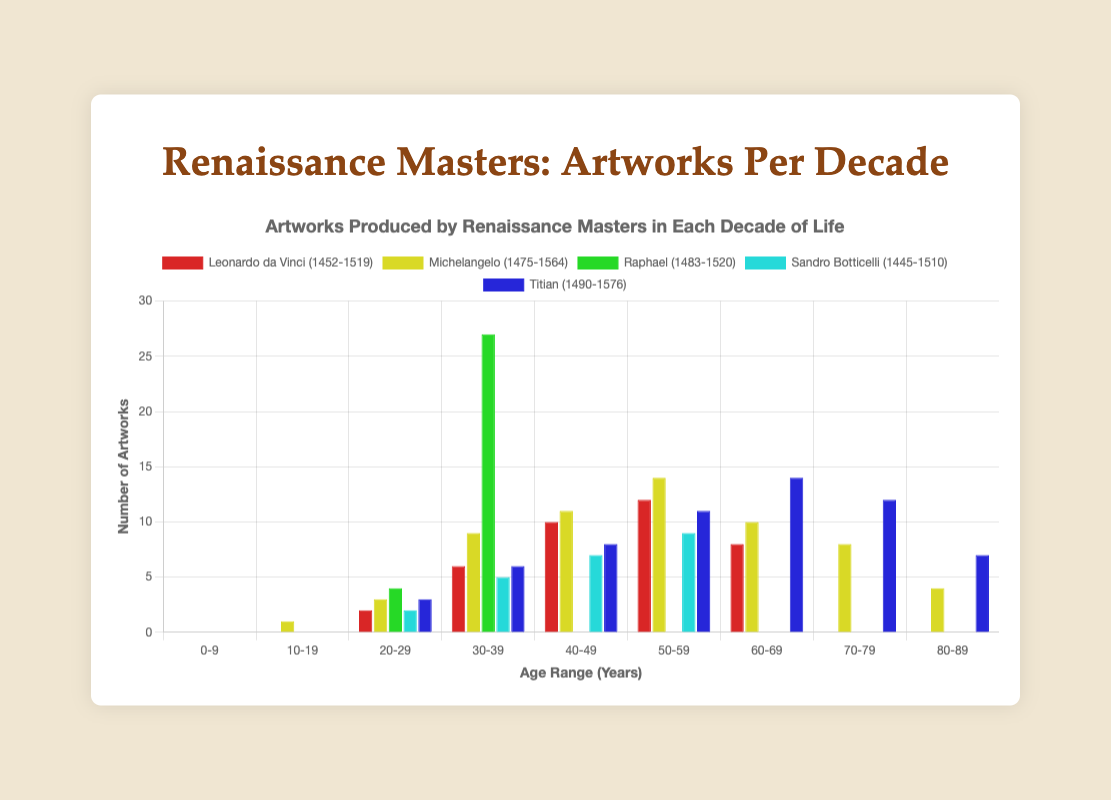Which artist produced the most artworks in their thirties? Looking at the decade labeled '30-39' on the x-axis, Raphael's bar is the tallest, reaching 27 artworks. Therefore, Raphael produced the most artworks in his thirties.
Answer: Raphael Which artist lived the longest? The lifespans of each artist are listed in the legend. Michelangelo lived from 1475 to 1564, making his lifespan 89 years.
Answer: Michelangelo Did Leonardo da Vinci create more artworks in his forties or fifties? Comparing the heights of the bars for '40-49' and '50-59' for Leonardo da Vinci, the bar for '50-59' is taller (12 artworks) than '40-49' (10 artworks).
Answer: Fifties How many artworks did Titian produce in his eighties? The number of artworks created by Titian in the '80-89' age range can be seen from the bar height, which is 7.
Answer: 7 Who created more artworks in their sixties, Michelangelo or Titian? Comparing the height of the bars for the '60-69' age range, Michelangelo produced 10 artworks while Titian produced 14. Titian's bar is taller.
Answer: Titian Which artist had the most productive decade in terms of the number of artworks? The highest single bar represents Raphael in the '30-39' age range with 27 artworks, indicating Raphael's productivity in his thirties.
Answer: Raphael What is the total number of artworks produced by Leonardo da Vinci in his sixties and seventies? Summing the artworks from the '60-69' and '70-79' age ranges for Leonardo da Vinci, we have 8 (sixties) + 0 (seventies) = 8.
Answer: 8 Compare the total artworks produced by Sandro Botticelli and Michelangelo in their forties. Sandro Botticelli produced 7 artworks in his '40-49' decade, while Michelangelo produced 11. Comparing both values, Michelangelo's production was higher.
Answer: Michelangelo How many artworks did all the artists collectively produce in their twenties? Adding up the artworks produced in the '20-29' age range by all artists: Leonardo da Vinci (2), Michelangelo (3), Raphael (4), Sandro Botticelli (2), Titian (3). The total is 2 + 3 + 4 + 2 + 3 = 14.
Answer: 14 